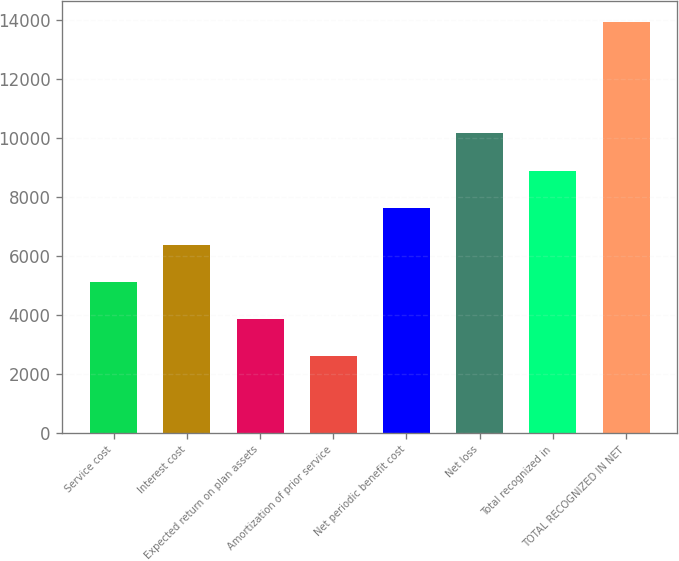Convert chart. <chart><loc_0><loc_0><loc_500><loc_500><bar_chart><fcel>Service cost<fcel>Interest cost<fcel>Expected return on plan assets<fcel>Amortization of prior service<fcel>Net periodic benefit cost<fcel>Net loss<fcel>Total recognized in<fcel>TOTAL RECOGNIZED IN NET<nl><fcel>5124.1<fcel>6384.8<fcel>3863.4<fcel>2602.7<fcel>7645.5<fcel>10166.9<fcel>8906.2<fcel>13949<nl></chart> 